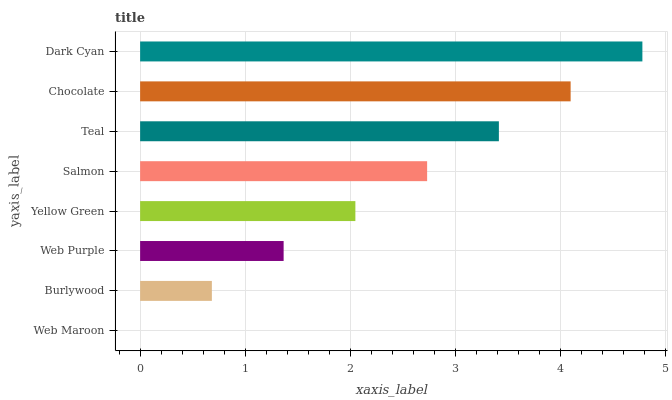Is Web Maroon the minimum?
Answer yes or no. Yes. Is Dark Cyan the maximum?
Answer yes or no. Yes. Is Burlywood the minimum?
Answer yes or no. No. Is Burlywood the maximum?
Answer yes or no. No. Is Burlywood greater than Web Maroon?
Answer yes or no. Yes. Is Web Maroon less than Burlywood?
Answer yes or no. Yes. Is Web Maroon greater than Burlywood?
Answer yes or no. No. Is Burlywood less than Web Maroon?
Answer yes or no. No. Is Salmon the high median?
Answer yes or no. Yes. Is Yellow Green the low median?
Answer yes or no. Yes. Is Yellow Green the high median?
Answer yes or no. No. Is Burlywood the low median?
Answer yes or no. No. 